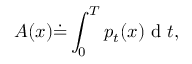Convert formula to latex. <formula><loc_0><loc_0><loc_500><loc_500>A ( x ) \dot { = } \int _ { 0 } ^ { T } p _ { t } ( x ) d t ,</formula> 